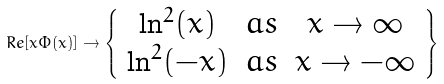<formula> <loc_0><loc_0><loc_500><loc_500>R e [ x \Phi ( x ) ] \rightarrow \left \{ \begin{array} { c c c } { { \ln ^ { 2 } ( x ) } } & { a s } & { x \rightarrow \infty } \\ { { \ln ^ { 2 } ( - x ) } } & { a s } & { x \rightarrow - \infty } \end{array} \right \}</formula> 